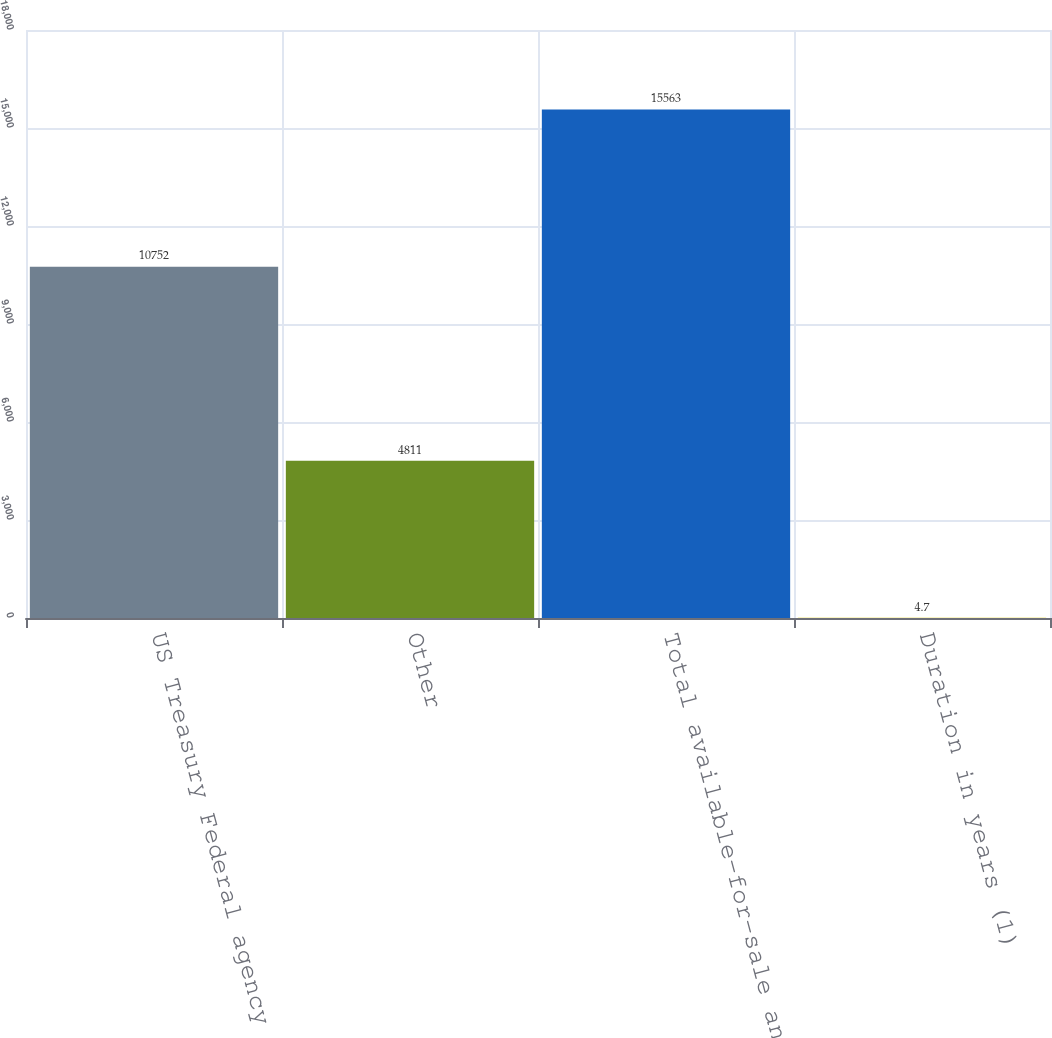Convert chart to OTSL. <chart><loc_0><loc_0><loc_500><loc_500><bar_chart><fcel>US Treasury Federal agency and<fcel>Other<fcel>Total available-for-sale and<fcel>Duration in years (1)<nl><fcel>10752<fcel>4811<fcel>15563<fcel>4.7<nl></chart> 